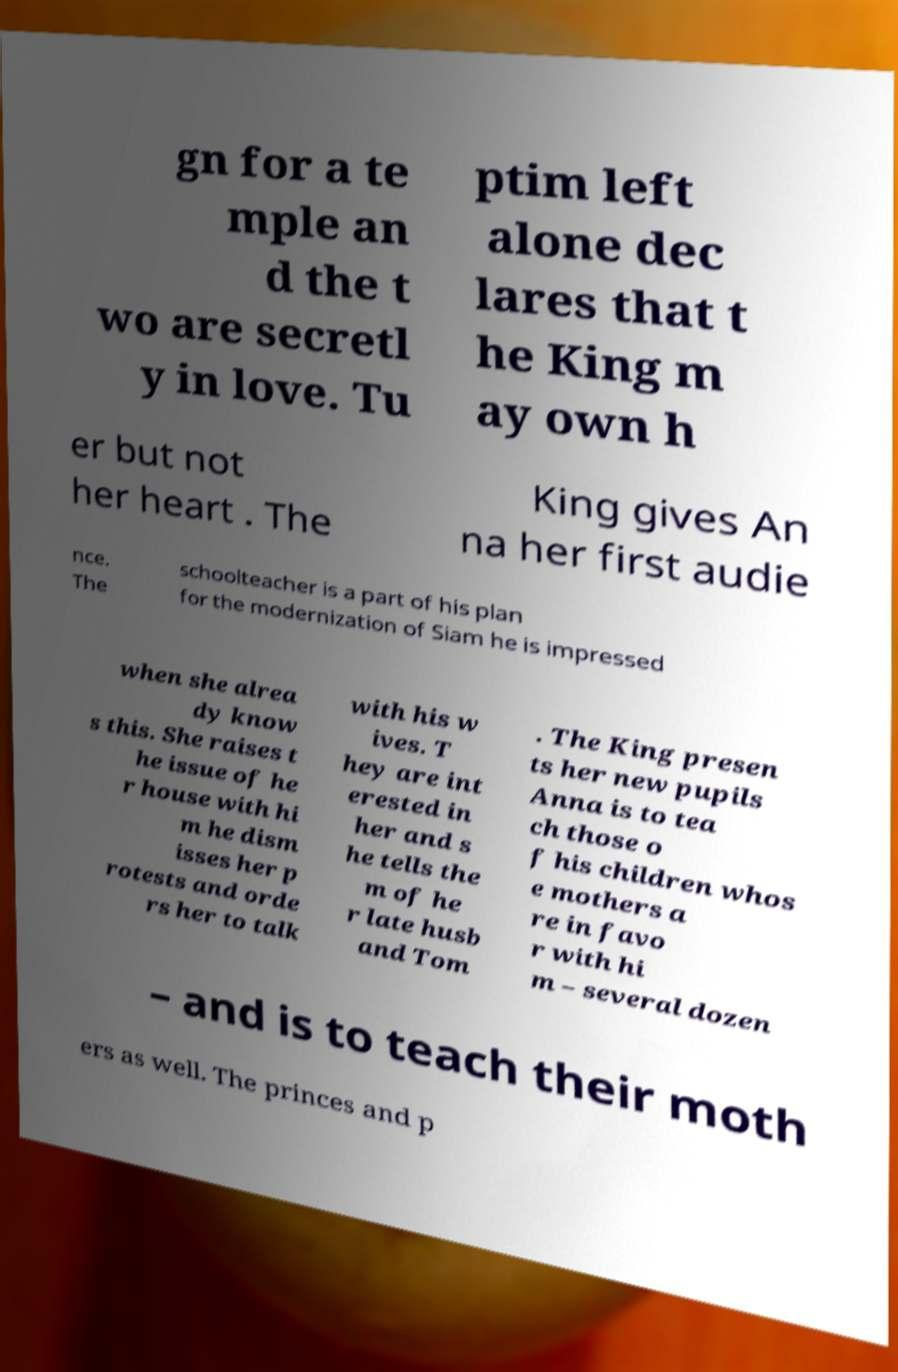Could you extract and type out the text from this image? gn for a te mple an d the t wo are secretl y in love. Tu ptim left alone dec lares that t he King m ay own h er but not her heart . The King gives An na her first audie nce. The schoolteacher is a part of his plan for the modernization of Siam he is impressed when she alrea dy know s this. She raises t he issue of he r house with hi m he dism isses her p rotests and orde rs her to talk with his w ives. T hey are int erested in her and s he tells the m of he r late husb and Tom . The King presen ts her new pupils Anna is to tea ch those o f his children whos e mothers a re in favo r with hi m – several dozen – and is to teach their moth ers as well. The princes and p 